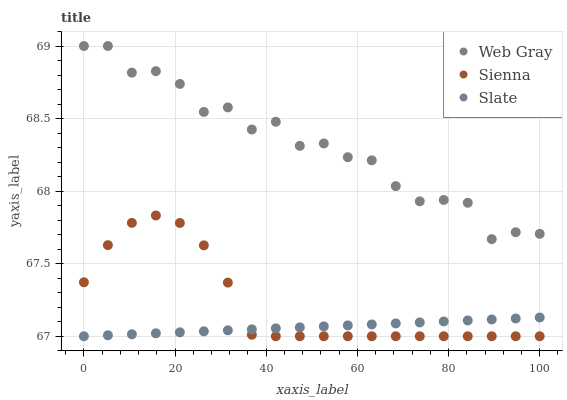Does Slate have the minimum area under the curve?
Answer yes or no. Yes. Does Web Gray have the maximum area under the curve?
Answer yes or no. Yes. Does Web Gray have the minimum area under the curve?
Answer yes or no. No. Does Slate have the maximum area under the curve?
Answer yes or no. No. Is Slate the smoothest?
Answer yes or no. Yes. Is Web Gray the roughest?
Answer yes or no. Yes. Is Web Gray the smoothest?
Answer yes or no. No. Is Slate the roughest?
Answer yes or no. No. Does Sienna have the lowest value?
Answer yes or no. Yes. Does Web Gray have the lowest value?
Answer yes or no. No. Does Web Gray have the highest value?
Answer yes or no. Yes. Does Slate have the highest value?
Answer yes or no. No. Is Slate less than Web Gray?
Answer yes or no. Yes. Is Web Gray greater than Sienna?
Answer yes or no. Yes. Does Sienna intersect Slate?
Answer yes or no. Yes. Is Sienna less than Slate?
Answer yes or no. No. Is Sienna greater than Slate?
Answer yes or no. No. Does Slate intersect Web Gray?
Answer yes or no. No. 